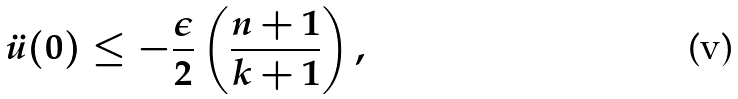<formula> <loc_0><loc_0><loc_500><loc_500>\ddot { u } ( 0 ) \leq - \frac { \epsilon } { 2 } \left ( \frac { n + 1 } { k + 1 } \right ) ,</formula> 